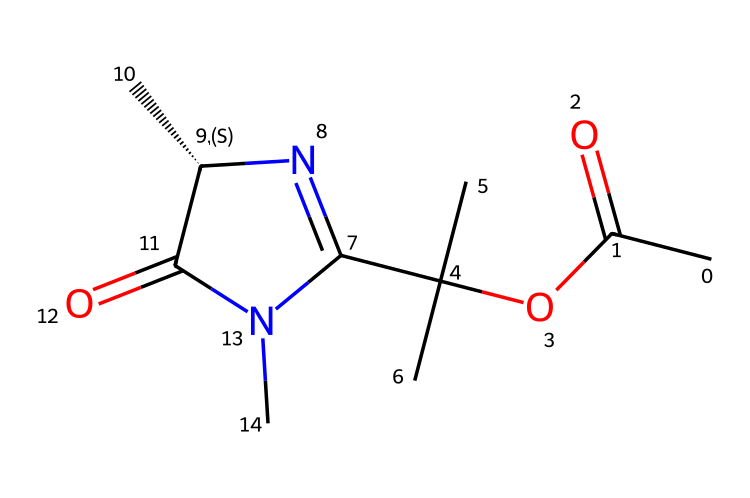What is the molecular weight of this compound? To calculate the molecular weight, we need to sum the atomic weights of each atom in the SMILES notation. The component atoms are carbon (C), hydrogen (H), oxygen (O), and nitrogen (N). Upon calculation, we find the total molecular weight to be approximately 206.3 g/mol.
Answer: 206.3 g/mol How many rings are present in the structure? By analyzing the SMILES representation, we can see that there is one nitrogen atom within a cyclic structure (indicated by 'C1' and 'N1'), which denotes that there is one ring present in this compound.
Answer: 1 What functional groups are present in this chemical? Looking at the SMILES, we identify ester (CC(=O)O) and amide (C(=O)N) functional groups due to the presence of carbonyl groups (C=O) bonded to oxygen and nitrogen atoms respectively, indicating their functional nature.
Answer: ester, amide Is there a carbene present in this structure? The presence of a carbon with an adjacent nitrogen and no other substituents, along with the C1=N highlights the existence of a carbene, which typically refers to a carbon atom that has only two substituents and retains two unshared electrons.
Answer: Yes What is the possible application of this compound in fuel additives? The presence of carbene-containing structures in fuel additives suggests that they can enhance engine performance through improved combustion efficiency and reduction of emissions; the specific molecular structure demonstrates characteristics desirable for such applications.
Answer: Improved combustion efficiency 